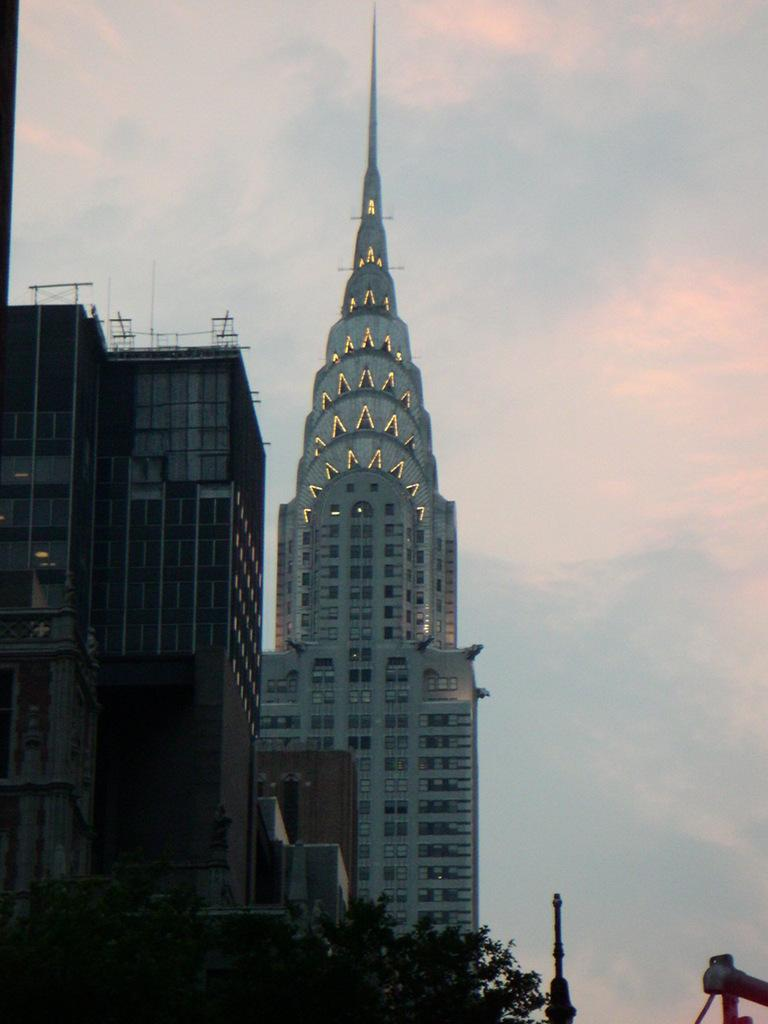What type of buildings can be seen on the right side of the image? There are buildings with glass windows on the right side of the image. What is the main feature of the tower in the background? The tower has glass windows and lights in the background of the image. What can be seen in the sky in the image? There are clouds in the sky. What is the twist in the image? There is no twist present in the image; it is a straightforward depiction of buildings, a tower, and clouds. What point is being made by the presence of the tower in the image? The image does not make a specific point about the tower; it simply shows the tower as part of the overall scene. 